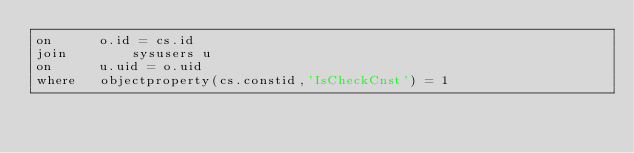<code> <loc_0><loc_0><loc_500><loc_500><_SQL_>on		o.id = cs.id
join		sysusers u
on		u.uid = o.uid
where 	objectproperty(cs.constid,'IsCheckCnst') = 1 


</code> 